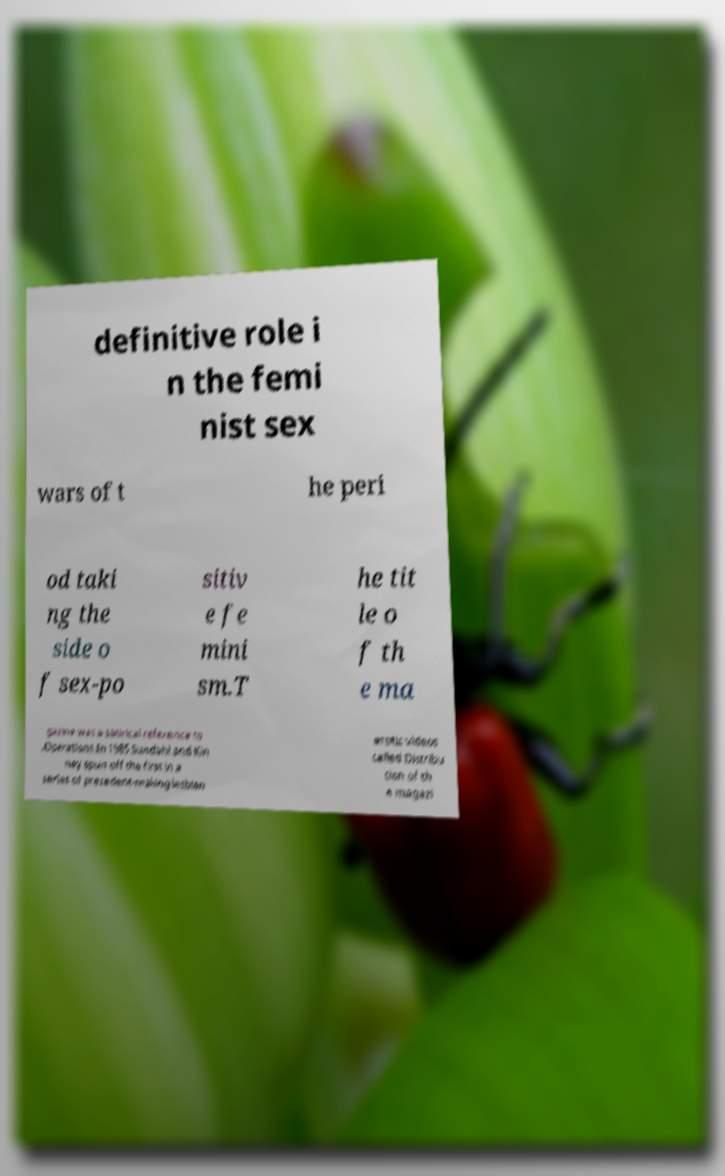Please identify and transcribe the text found in this image. definitive role i n the femi nist sex wars of t he peri od taki ng the side o f sex-po sitiv e fe mini sm.T he tit le o f th e ma gazine was a satirical reference to .Operations.In 1985 Sundahl and Kin ney spun off the first in a series of precedent-making lesbian erotic videos called Distribu tion of th e magazi 